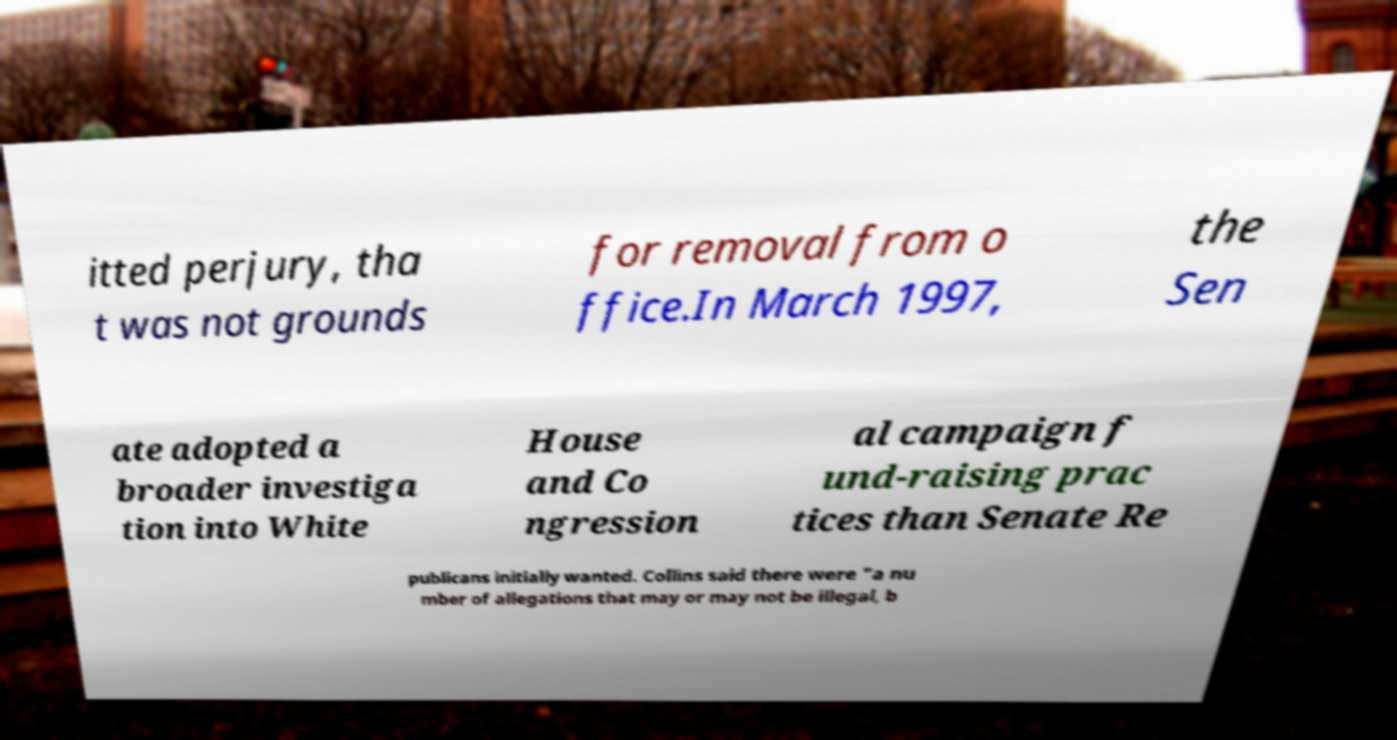I need the written content from this picture converted into text. Can you do that? itted perjury, tha t was not grounds for removal from o ffice.In March 1997, the Sen ate adopted a broader investiga tion into White House and Co ngression al campaign f und-raising prac tices than Senate Re publicans initially wanted. Collins said there were "a nu mber of allegations that may or may not be illegal, b 